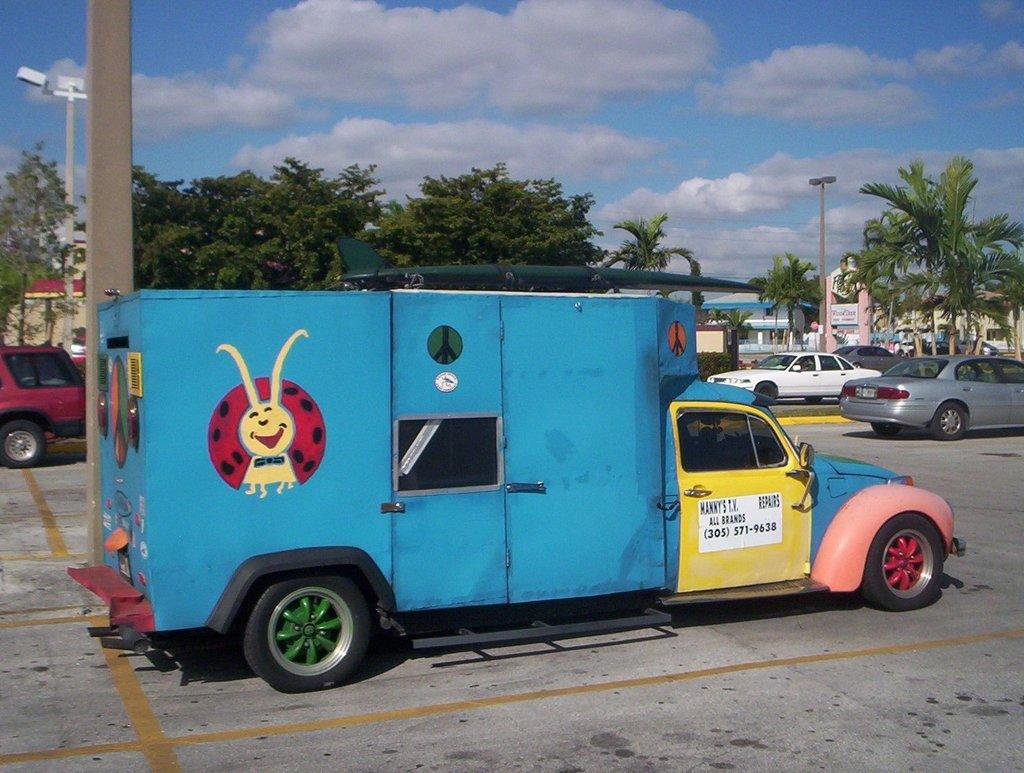What type of vehicle is in the image? There is a blue truck in the image. What is at the bottom of the image? There is a road at the bottom of the image. What can be seen in the background of the image? There are cars and trees in the background of the image. What is visible in the sky at the top of the image? There are clouds in the sky at the top of the image. What type of liquid is being served on the plate in the image? There is no plate or liquid present in the image. 